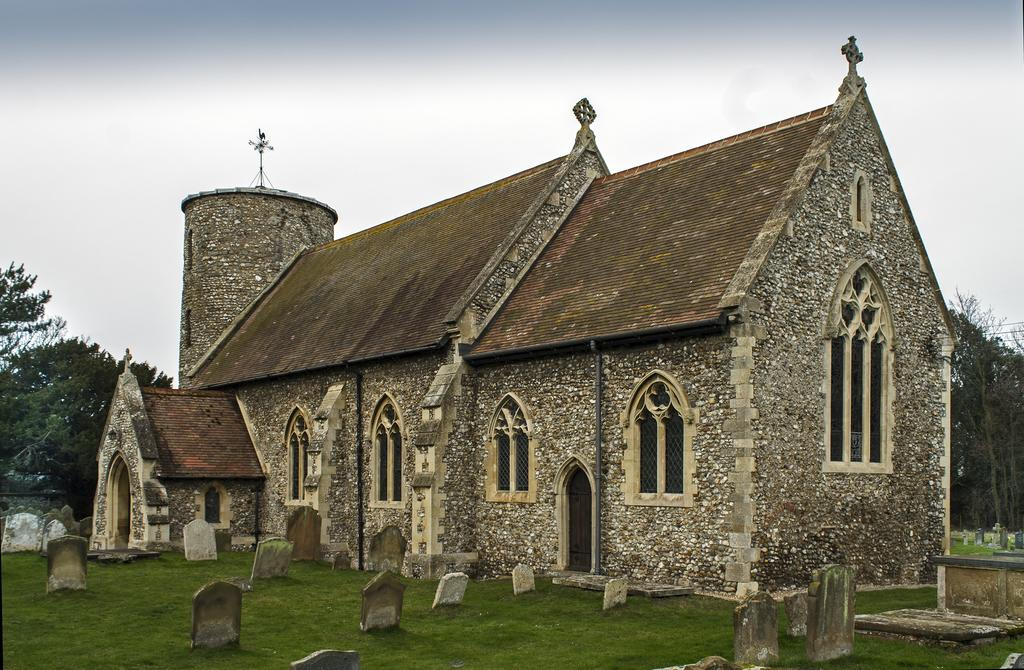What type of building is in the image? There is an old church building in the image. What is located near the church? There is a grass surface with grave stones near the church. What can be seen behind the church? There are trees visible behind the church. What is visible in the sky in the image? The sky is visible in the image. How does the rake help to increase the number of trees in the image? There is no rake present in the image, and therefore it cannot be used to increase the number of trees. 